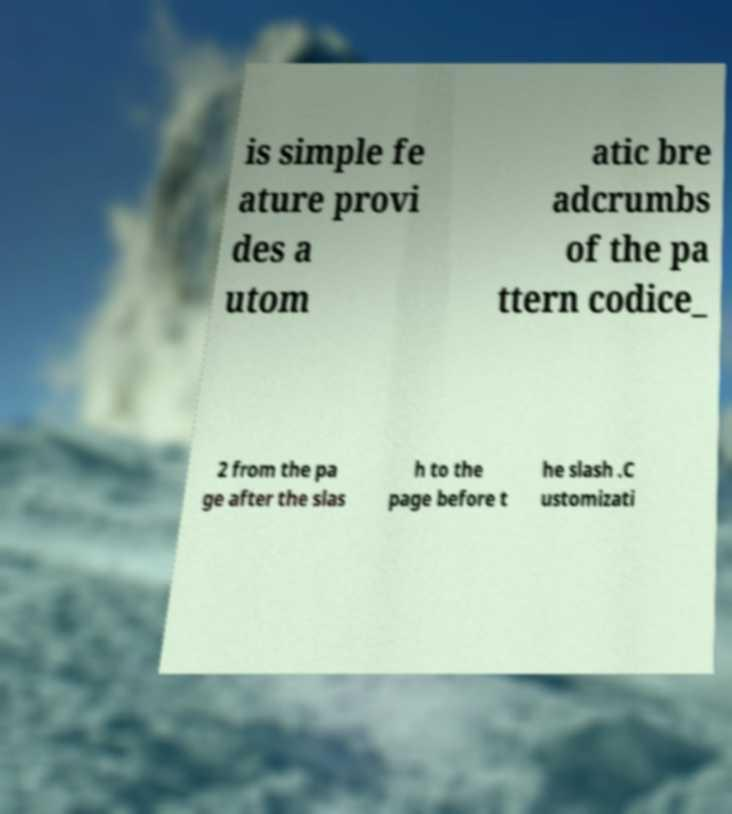Can you read and provide the text displayed in the image?This photo seems to have some interesting text. Can you extract and type it out for me? is simple fe ature provi des a utom atic bre adcrumbs of the pa ttern codice_ 2 from the pa ge after the slas h to the page before t he slash .C ustomizati 